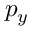Convert formula to latex. <formula><loc_0><loc_0><loc_500><loc_500>p _ { y }</formula> 